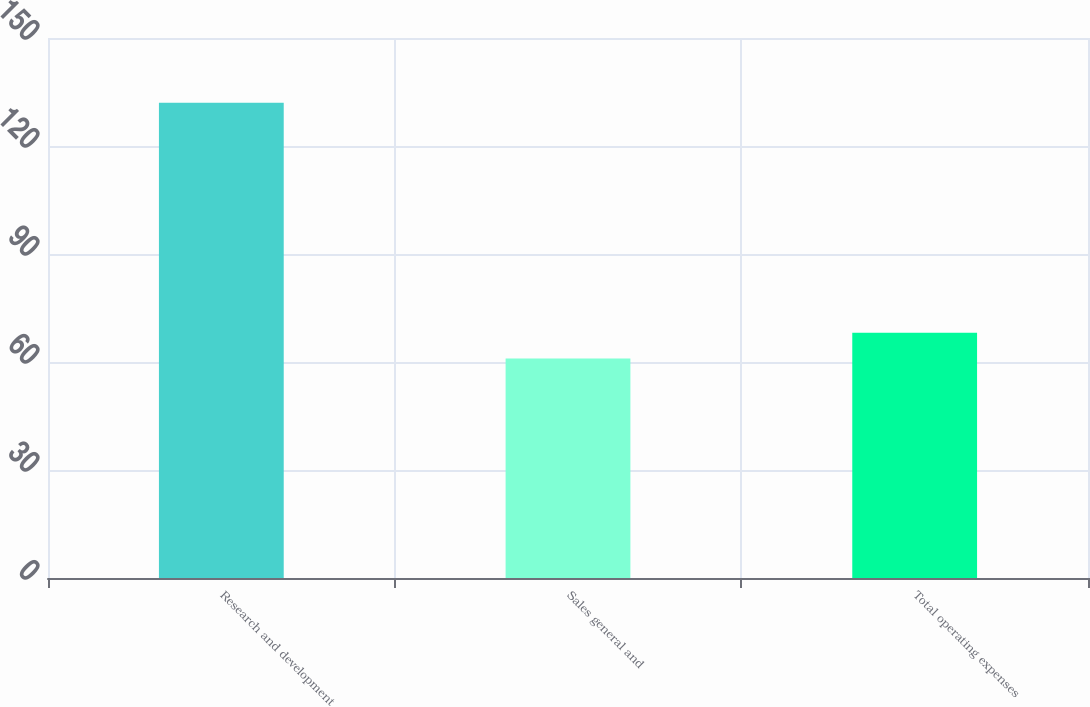Convert chart. <chart><loc_0><loc_0><loc_500><loc_500><bar_chart><fcel>Research and development<fcel>Sales general and<fcel>Total operating expenses<nl><fcel>132<fcel>61<fcel>68.1<nl></chart> 